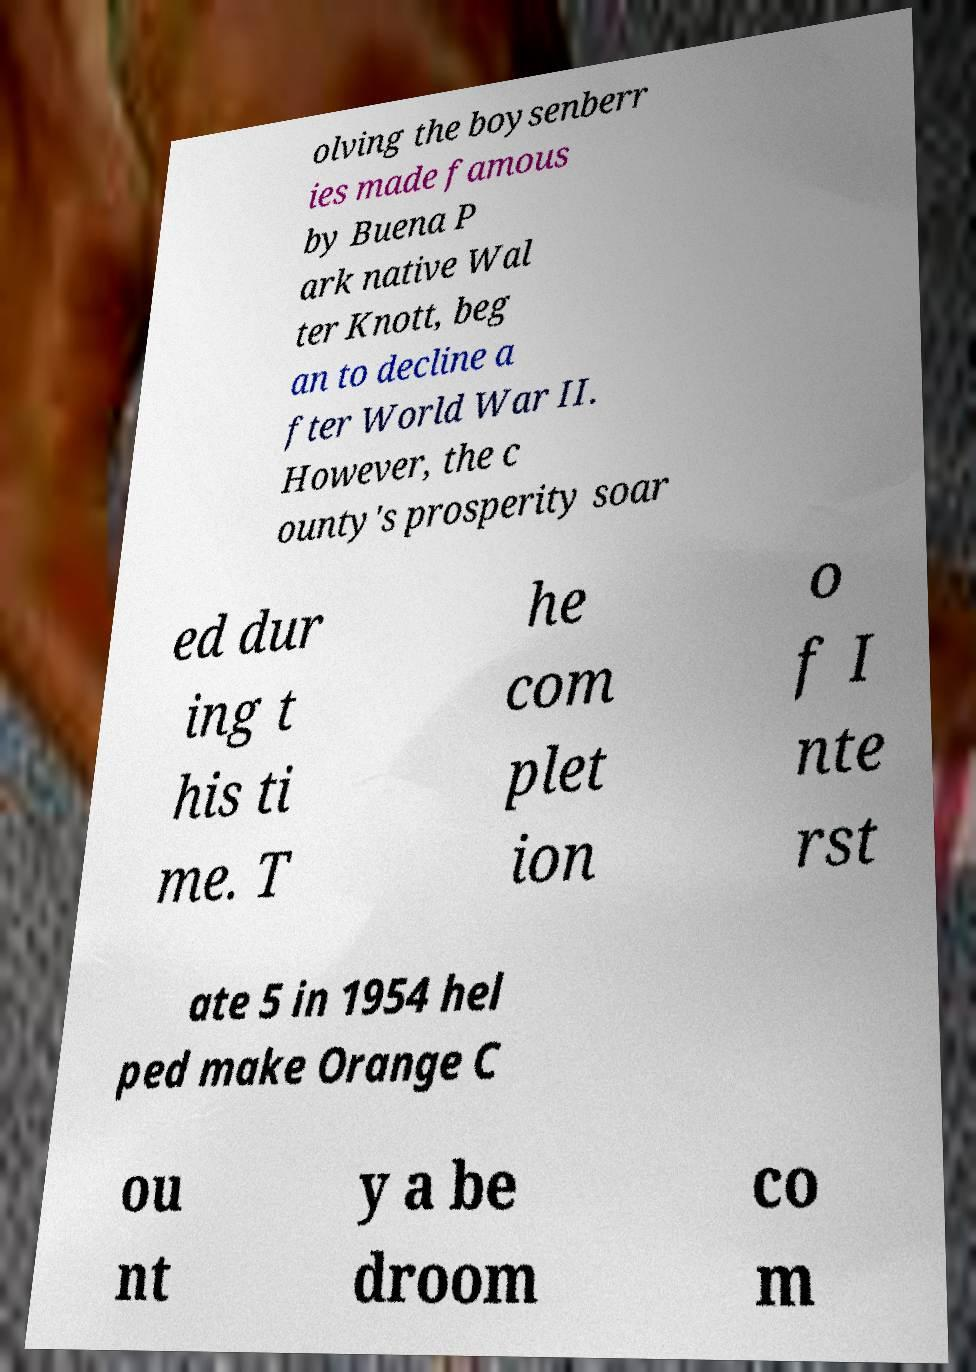Can you read and provide the text displayed in the image?This photo seems to have some interesting text. Can you extract and type it out for me? olving the boysenberr ies made famous by Buena P ark native Wal ter Knott, beg an to decline a fter World War II. However, the c ounty's prosperity soar ed dur ing t his ti me. T he com plet ion o f I nte rst ate 5 in 1954 hel ped make Orange C ou nt y a be droom co m 